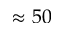Convert formula to latex. <formula><loc_0><loc_0><loc_500><loc_500>\approx 5 0</formula> 